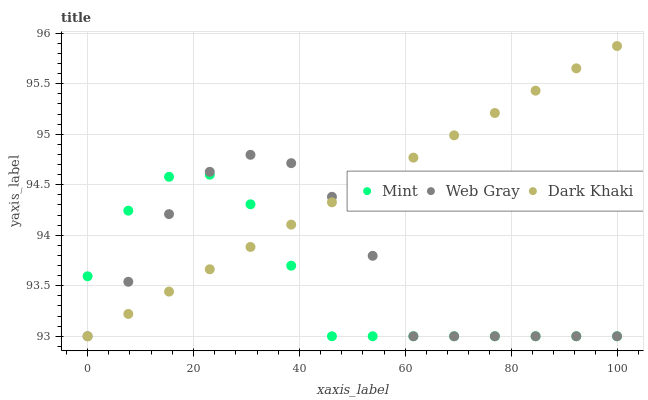Does Mint have the minimum area under the curve?
Answer yes or no. Yes. Does Dark Khaki have the maximum area under the curve?
Answer yes or no. Yes. Does Web Gray have the minimum area under the curve?
Answer yes or no. No. Does Web Gray have the maximum area under the curve?
Answer yes or no. No. Is Dark Khaki the smoothest?
Answer yes or no. Yes. Is Web Gray the roughest?
Answer yes or no. Yes. Is Mint the smoothest?
Answer yes or no. No. Is Mint the roughest?
Answer yes or no. No. Does Dark Khaki have the lowest value?
Answer yes or no. Yes. Does Dark Khaki have the highest value?
Answer yes or no. Yes. Does Web Gray have the highest value?
Answer yes or no. No. Does Dark Khaki intersect Mint?
Answer yes or no. Yes. Is Dark Khaki less than Mint?
Answer yes or no. No. Is Dark Khaki greater than Mint?
Answer yes or no. No. 